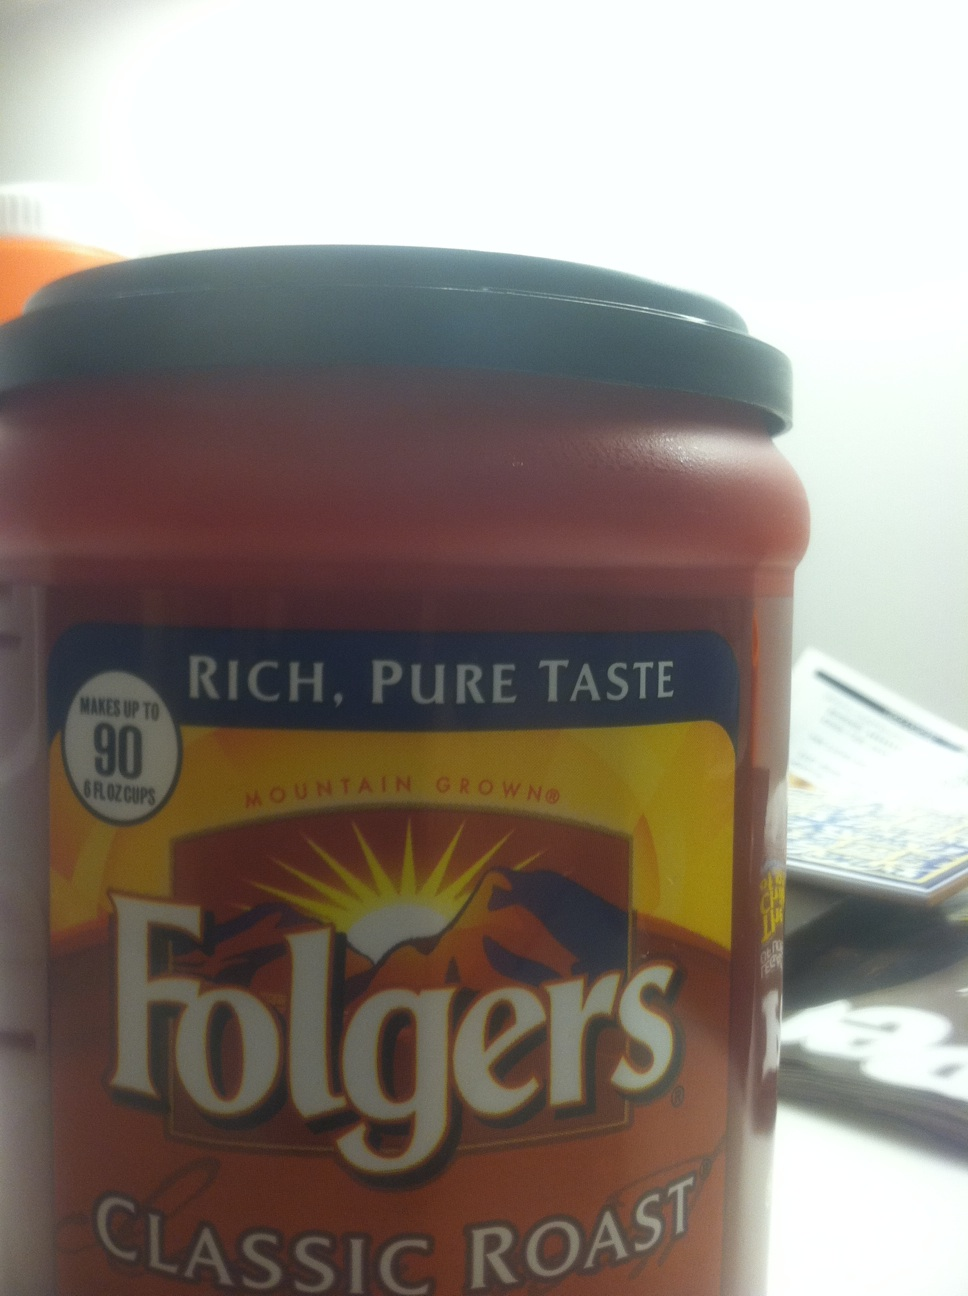What is the significance of 'Mountain Grown' as stated on the coffee label? 'Mountain Grown' is a term used by Folgers to indicate that the coffee beans they use are sourced from mountainside regions, which are often associated with high-quality coffee due to the optimal growing conditions found at high altitudes. This may include factors like cooler temperatures and volcanic soil, both of which can contribute to the beans' flavor complexity. 